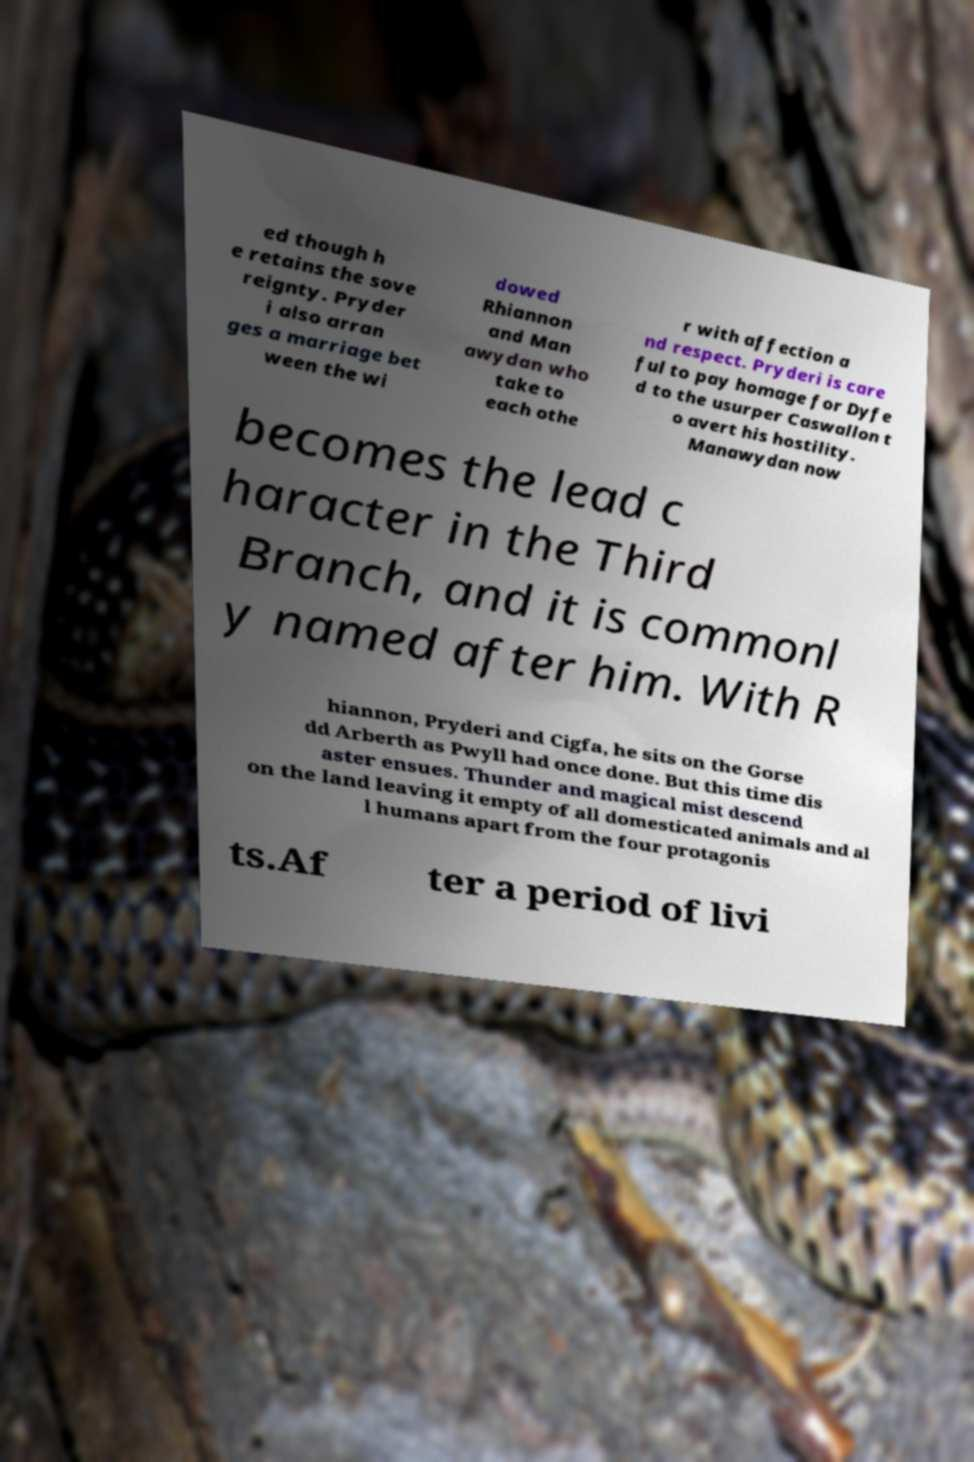Can you accurately transcribe the text from the provided image for me? ed though h e retains the sove reignty. Pryder i also arran ges a marriage bet ween the wi dowed Rhiannon and Man awydan who take to each othe r with affection a nd respect. Pryderi is care ful to pay homage for Dyfe d to the usurper Caswallon t o avert his hostility. Manawydan now becomes the lead c haracter in the Third Branch, and it is commonl y named after him. With R hiannon, Pryderi and Cigfa, he sits on the Gorse dd Arberth as Pwyll had once done. But this time dis aster ensues. Thunder and magical mist descend on the land leaving it empty of all domesticated animals and al l humans apart from the four protagonis ts.Af ter a period of livi 